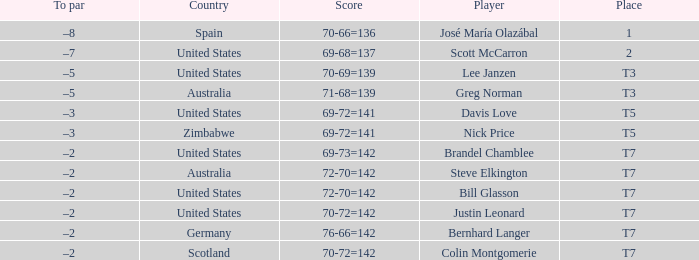WHich Score has a To par of –3, and a Country of united states? 69-72=141. 